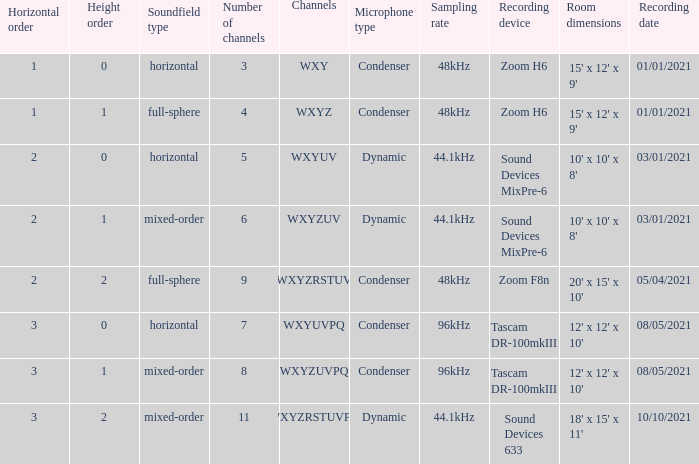If the channels is wxyzuv, what is the number of channels? 6.0. 